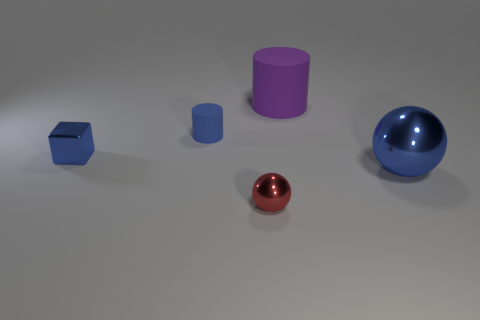There is another purple matte object that is the same shape as the tiny matte thing; what size is it? The larger purple matte object in the image shares the same cylindrical shape as the smaller one but is noticeably bigger, possibly around four times the height of the smaller cylinder when compared by visible scale. 